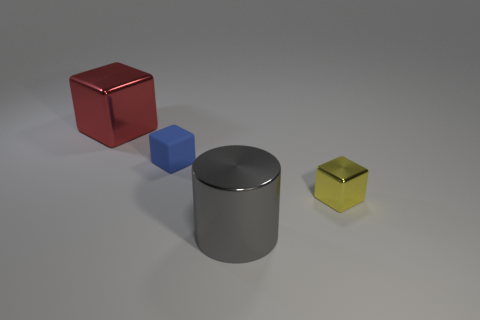What number of other things are there of the same material as the blue block
Provide a succinct answer. 0. Are there fewer small brown shiny balls than gray shiny objects?
Provide a succinct answer. Yes. Do the large cylinder and the tiny thing behind the yellow metallic block have the same material?
Ensure brevity in your answer.  No. There is a tiny yellow thing that is in front of the red metal object; what shape is it?
Your answer should be very brief. Cube. Is there any other thing that is the same color as the big cylinder?
Give a very brief answer. No. Is the number of blue rubber cubes to the left of the large red metal thing less than the number of yellow metallic things?
Make the answer very short. Yes. How many other gray cylinders have the same size as the metal cylinder?
Keep it short and to the point. 0. There is a large shiny object to the right of the metallic block that is to the left of the shiny block in front of the big red cube; what is its shape?
Provide a short and direct response. Cylinder. There is a cube that is in front of the blue matte cube; what is its color?
Make the answer very short. Yellow. How many objects are large objects that are to the left of the gray cylinder or big objects that are to the right of the large red metallic object?
Your response must be concise. 2. 